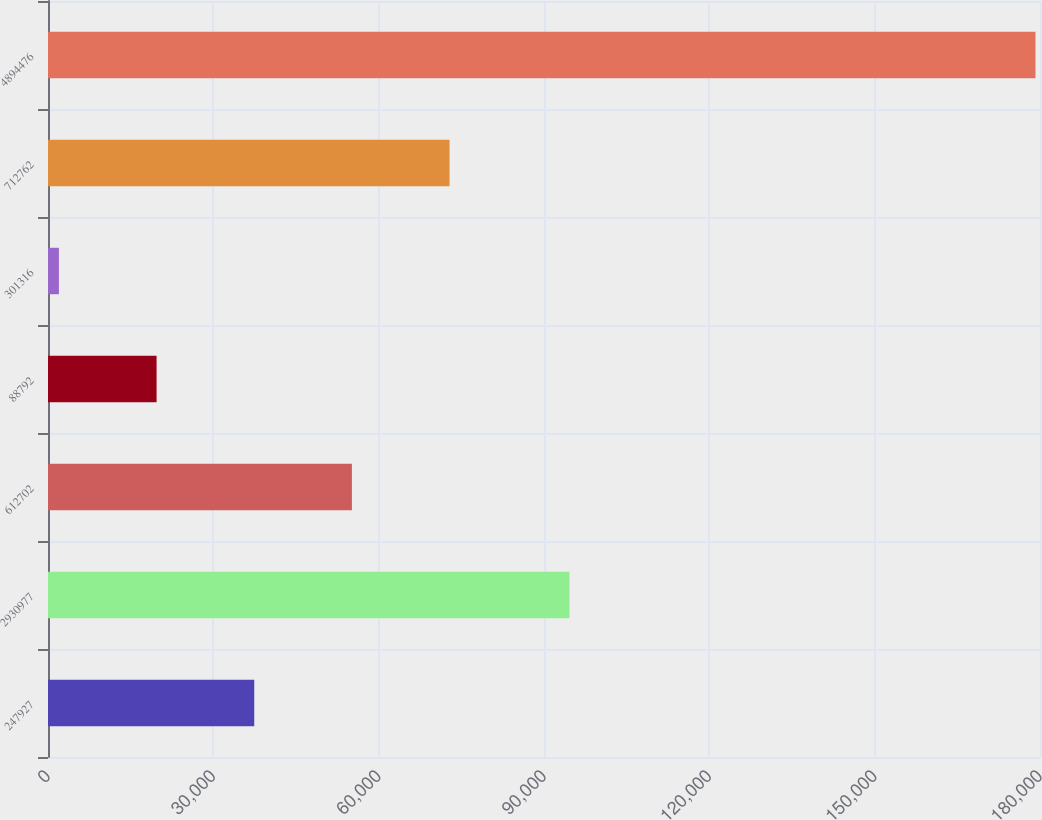<chart> <loc_0><loc_0><loc_500><loc_500><bar_chart><fcel>247927<fcel>2930977<fcel>612702<fcel>88792<fcel>301316<fcel>712762<fcel>4894476<nl><fcel>37421.8<fcel>94623<fcel>55141.7<fcel>19701.9<fcel>1982<fcel>72861.6<fcel>179181<nl></chart> 